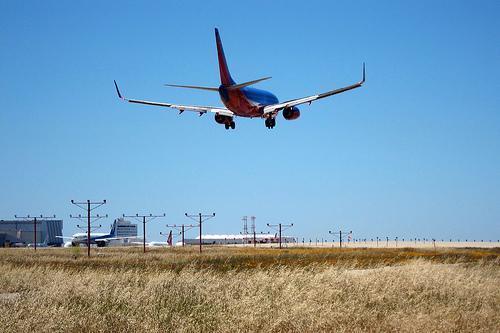How many planes are in the sky?
Give a very brief answer. 1. 